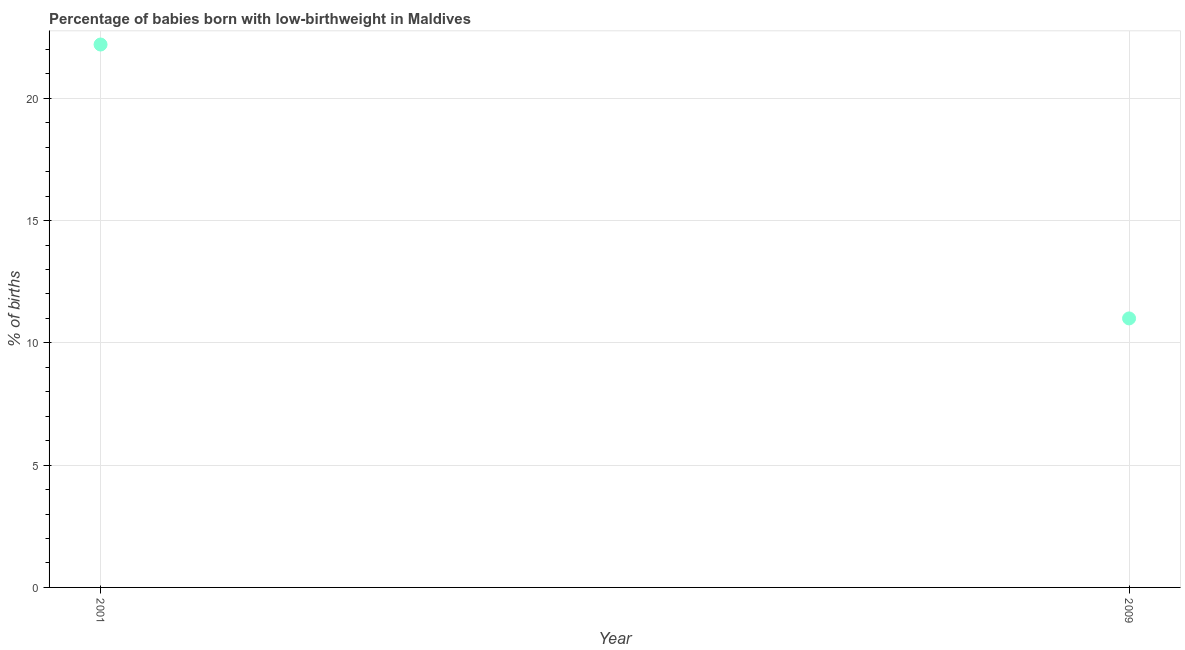Across all years, what is the maximum percentage of babies who were born with low-birthweight?
Offer a very short reply. 22.2. What is the sum of the percentage of babies who were born with low-birthweight?
Provide a short and direct response. 33.2. Do a majority of the years between 2001 and 2009 (inclusive) have percentage of babies who were born with low-birthweight greater than 16 %?
Offer a terse response. No. What is the ratio of the percentage of babies who were born with low-birthweight in 2001 to that in 2009?
Give a very brief answer. 2.02. Is the percentage of babies who were born with low-birthweight in 2001 less than that in 2009?
Ensure brevity in your answer.  No. In how many years, is the percentage of babies who were born with low-birthweight greater than the average percentage of babies who were born with low-birthweight taken over all years?
Your answer should be very brief. 1. Does the percentage of babies who were born with low-birthweight monotonically increase over the years?
Make the answer very short. No. Are the values on the major ticks of Y-axis written in scientific E-notation?
Your answer should be compact. No. Does the graph contain any zero values?
Your response must be concise. No. Does the graph contain grids?
Provide a short and direct response. Yes. What is the title of the graph?
Offer a terse response. Percentage of babies born with low-birthweight in Maldives. What is the label or title of the Y-axis?
Provide a short and direct response. % of births. What is the ratio of the % of births in 2001 to that in 2009?
Your answer should be very brief. 2.02. 